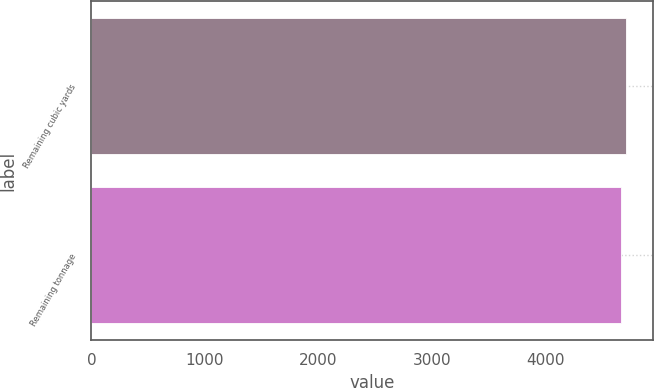Convert chart to OTSL. <chart><loc_0><loc_0><loc_500><loc_500><bar_chart><fcel>Remaining cubic yards<fcel>Remaining tonnage<nl><fcel>4708<fcel>4660<nl></chart> 